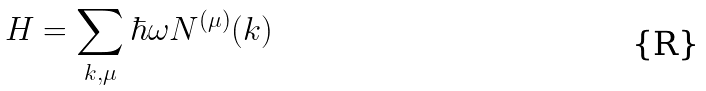<formula> <loc_0><loc_0><loc_500><loc_500>H = \sum _ { k , \mu } \hbar { \omega } N ^ { ( \mu ) } ( k )</formula> 